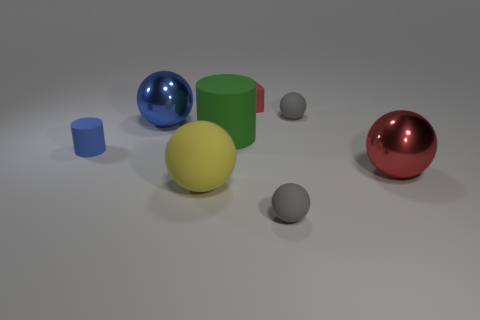How many gray balls must be subtracted to get 1 gray balls? 1 Subtract all matte spheres. How many spheres are left? 2 Add 1 large purple metal cylinders. How many objects exist? 9 Subtract all spheres. How many objects are left? 3 Subtract all red spheres. How many spheres are left? 4 Subtract 0 gray blocks. How many objects are left? 8 Subtract 1 cubes. How many cubes are left? 0 Subtract all red balls. Subtract all cyan cylinders. How many balls are left? 4 Subtract all green blocks. How many gray balls are left? 2 Subtract all tiny blue cylinders. Subtract all blue things. How many objects are left? 5 